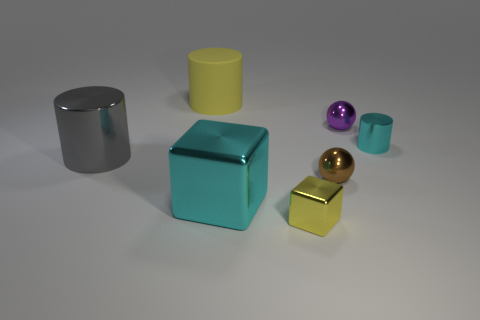Subtract all large yellow cylinders. How many cylinders are left? 2 Subtract all cyan cylinders. How many cylinders are left? 2 Subtract all balls. How many objects are left? 5 Subtract 1 balls. How many balls are left? 1 Subtract all big brown metal blocks. Subtract all large cyan metal things. How many objects are left? 6 Add 4 small brown metal objects. How many small brown metal objects are left? 5 Add 7 large gray things. How many large gray things exist? 8 Add 1 small yellow blocks. How many objects exist? 8 Subtract 1 purple balls. How many objects are left? 6 Subtract all blue cylinders. Subtract all purple balls. How many cylinders are left? 3 